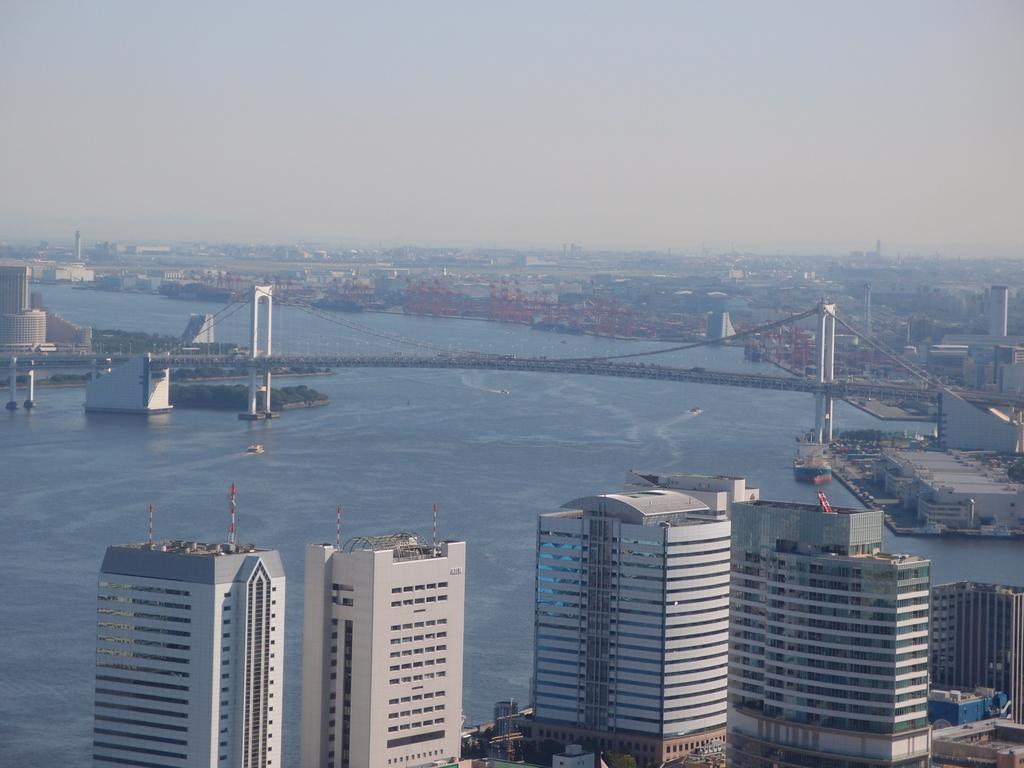What type of structures can be seen in the image? There are buildings in the image. What can be seen in the background of the image? There is a bridge and water visible in the background of the image. What type of experience can be gained from visiting the hall in the image? There is no hall present in the image, so it is not possible to gain any experience from visiting it. 